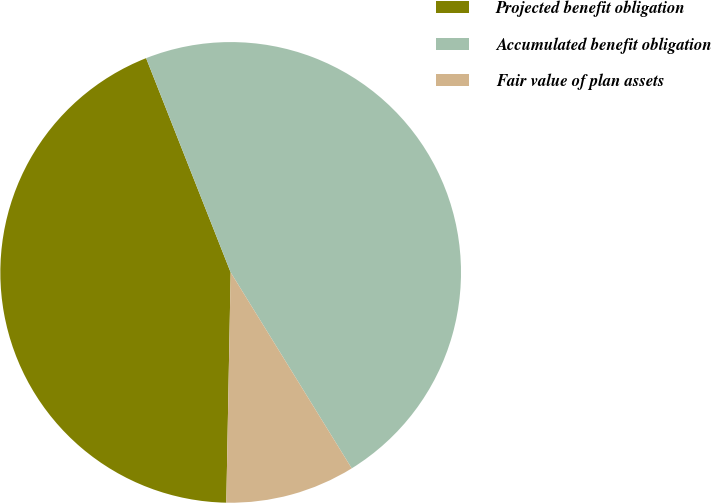Convert chart. <chart><loc_0><loc_0><loc_500><loc_500><pie_chart><fcel>Projected benefit obligation<fcel>Accumulated benefit obligation<fcel>Fair value of plan assets<nl><fcel>43.72%<fcel>47.18%<fcel>9.11%<nl></chart> 